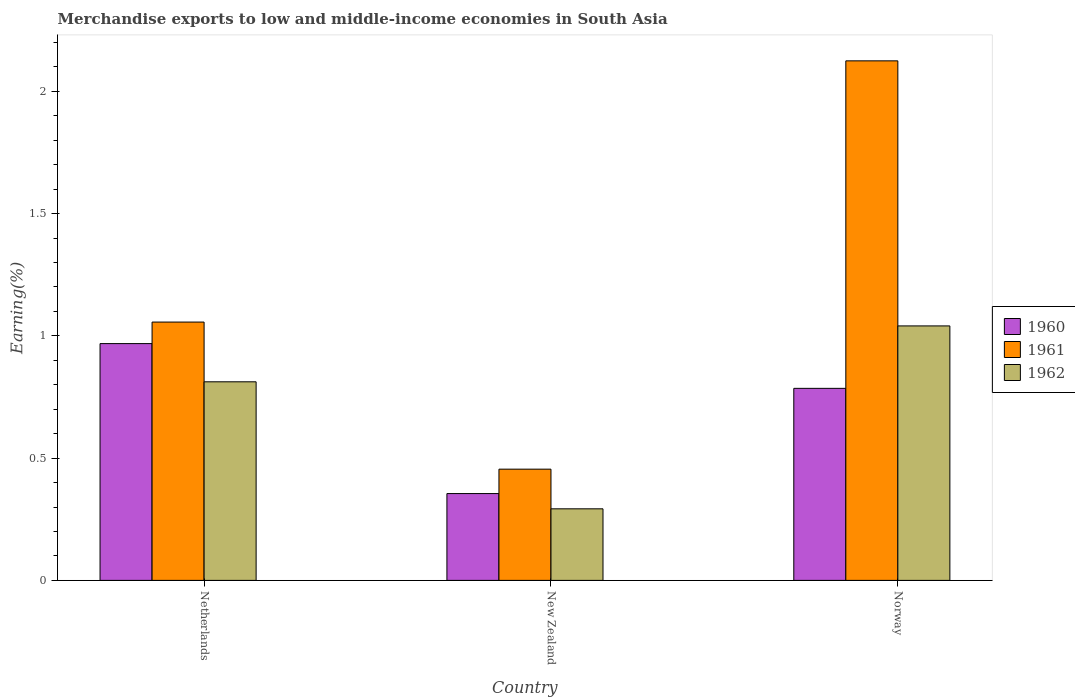How many groups of bars are there?
Give a very brief answer. 3. Are the number of bars per tick equal to the number of legend labels?
Your answer should be very brief. Yes. How many bars are there on the 3rd tick from the right?
Your answer should be very brief. 3. In how many cases, is the number of bars for a given country not equal to the number of legend labels?
Provide a succinct answer. 0. What is the percentage of amount earned from merchandise exports in 1961 in Norway?
Give a very brief answer. 2.12. Across all countries, what is the maximum percentage of amount earned from merchandise exports in 1962?
Ensure brevity in your answer.  1.04. Across all countries, what is the minimum percentage of amount earned from merchandise exports in 1962?
Ensure brevity in your answer.  0.29. In which country was the percentage of amount earned from merchandise exports in 1961 minimum?
Ensure brevity in your answer.  New Zealand. What is the total percentage of amount earned from merchandise exports in 1960 in the graph?
Keep it short and to the point. 2.11. What is the difference between the percentage of amount earned from merchandise exports in 1960 in New Zealand and that in Norway?
Provide a short and direct response. -0.43. What is the difference between the percentage of amount earned from merchandise exports in 1962 in Netherlands and the percentage of amount earned from merchandise exports in 1961 in New Zealand?
Provide a succinct answer. 0.36. What is the average percentage of amount earned from merchandise exports in 1960 per country?
Your response must be concise. 0.7. What is the difference between the percentage of amount earned from merchandise exports of/in 1960 and percentage of amount earned from merchandise exports of/in 1962 in New Zealand?
Offer a terse response. 0.06. What is the ratio of the percentage of amount earned from merchandise exports in 1962 in Netherlands to that in Norway?
Your response must be concise. 0.78. Is the percentage of amount earned from merchandise exports in 1961 in Netherlands less than that in New Zealand?
Offer a terse response. No. What is the difference between the highest and the second highest percentage of amount earned from merchandise exports in 1961?
Your answer should be very brief. -0.6. What is the difference between the highest and the lowest percentage of amount earned from merchandise exports in 1961?
Your answer should be very brief. 1.67. In how many countries, is the percentage of amount earned from merchandise exports in 1962 greater than the average percentage of amount earned from merchandise exports in 1962 taken over all countries?
Provide a succinct answer. 2. What does the 2nd bar from the right in Norway represents?
Ensure brevity in your answer.  1961. Is it the case that in every country, the sum of the percentage of amount earned from merchandise exports in 1960 and percentage of amount earned from merchandise exports in 1961 is greater than the percentage of amount earned from merchandise exports in 1962?
Your answer should be very brief. Yes. How many bars are there?
Provide a succinct answer. 9. How many countries are there in the graph?
Ensure brevity in your answer.  3. What is the difference between two consecutive major ticks on the Y-axis?
Offer a terse response. 0.5. Are the values on the major ticks of Y-axis written in scientific E-notation?
Offer a terse response. No. Does the graph contain any zero values?
Offer a terse response. No. How are the legend labels stacked?
Ensure brevity in your answer.  Vertical. What is the title of the graph?
Your answer should be very brief. Merchandise exports to low and middle-income economies in South Asia. Does "1967" appear as one of the legend labels in the graph?
Offer a terse response. No. What is the label or title of the X-axis?
Offer a terse response. Country. What is the label or title of the Y-axis?
Make the answer very short. Earning(%). What is the Earning(%) in 1960 in Netherlands?
Provide a short and direct response. 0.97. What is the Earning(%) in 1961 in Netherlands?
Your answer should be compact. 1.06. What is the Earning(%) in 1962 in Netherlands?
Your answer should be compact. 0.81. What is the Earning(%) of 1960 in New Zealand?
Provide a succinct answer. 0.36. What is the Earning(%) in 1961 in New Zealand?
Provide a short and direct response. 0.45. What is the Earning(%) of 1962 in New Zealand?
Offer a very short reply. 0.29. What is the Earning(%) of 1960 in Norway?
Make the answer very short. 0.79. What is the Earning(%) in 1961 in Norway?
Your answer should be compact. 2.12. What is the Earning(%) of 1962 in Norway?
Provide a succinct answer. 1.04. Across all countries, what is the maximum Earning(%) of 1960?
Keep it short and to the point. 0.97. Across all countries, what is the maximum Earning(%) of 1961?
Your answer should be very brief. 2.12. Across all countries, what is the maximum Earning(%) of 1962?
Your answer should be very brief. 1.04. Across all countries, what is the minimum Earning(%) in 1960?
Your answer should be very brief. 0.36. Across all countries, what is the minimum Earning(%) of 1961?
Make the answer very short. 0.45. Across all countries, what is the minimum Earning(%) in 1962?
Your answer should be very brief. 0.29. What is the total Earning(%) in 1960 in the graph?
Give a very brief answer. 2.11. What is the total Earning(%) in 1961 in the graph?
Provide a succinct answer. 3.64. What is the total Earning(%) of 1962 in the graph?
Provide a short and direct response. 2.15. What is the difference between the Earning(%) in 1960 in Netherlands and that in New Zealand?
Provide a short and direct response. 0.61. What is the difference between the Earning(%) in 1961 in Netherlands and that in New Zealand?
Provide a succinct answer. 0.6. What is the difference between the Earning(%) of 1962 in Netherlands and that in New Zealand?
Offer a very short reply. 0.52. What is the difference between the Earning(%) of 1960 in Netherlands and that in Norway?
Offer a terse response. 0.18. What is the difference between the Earning(%) in 1961 in Netherlands and that in Norway?
Offer a very short reply. -1.07. What is the difference between the Earning(%) of 1962 in Netherlands and that in Norway?
Keep it short and to the point. -0.23. What is the difference between the Earning(%) in 1960 in New Zealand and that in Norway?
Your response must be concise. -0.43. What is the difference between the Earning(%) of 1961 in New Zealand and that in Norway?
Ensure brevity in your answer.  -1.67. What is the difference between the Earning(%) in 1962 in New Zealand and that in Norway?
Your answer should be very brief. -0.75. What is the difference between the Earning(%) of 1960 in Netherlands and the Earning(%) of 1961 in New Zealand?
Make the answer very short. 0.51. What is the difference between the Earning(%) in 1960 in Netherlands and the Earning(%) in 1962 in New Zealand?
Provide a succinct answer. 0.68. What is the difference between the Earning(%) of 1961 in Netherlands and the Earning(%) of 1962 in New Zealand?
Offer a terse response. 0.76. What is the difference between the Earning(%) in 1960 in Netherlands and the Earning(%) in 1961 in Norway?
Your response must be concise. -1.16. What is the difference between the Earning(%) of 1960 in Netherlands and the Earning(%) of 1962 in Norway?
Offer a terse response. -0.07. What is the difference between the Earning(%) of 1961 in Netherlands and the Earning(%) of 1962 in Norway?
Provide a short and direct response. 0.02. What is the difference between the Earning(%) in 1960 in New Zealand and the Earning(%) in 1961 in Norway?
Your answer should be compact. -1.77. What is the difference between the Earning(%) in 1960 in New Zealand and the Earning(%) in 1962 in Norway?
Offer a terse response. -0.69. What is the difference between the Earning(%) of 1961 in New Zealand and the Earning(%) of 1962 in Norway?
Provide a succinct answer. -0.59. What is the average Earning(%) of 1960 per country?
Offer a terse response. 0.7. What is the average Earning(%) of 1961 per country?
Make the answer very short. 1.21. What is the average Earning(%) of 1962 per country?
Make the answer very short. 0.72. What is the difference between the Earning(%) of 1960 and Earning(%) of 1961 in Netherlands?
Provide a short and direct response. -0.09. What is the difference between the Earning(%) in 1960 and Earning(%) in 1962 in Netherlands?
Ensure brevity in your answer.  0.16. What is the difference between the Earning(%) in 1961 and Earning(%) in 1962 in Netherlands?
Your answer should be compact. 0.24. What is the difference between the Earning(%) of 1960 and Earning(%) of 1961 in New Zealand?
Offer a terse response. -0.1. What is the difference between the Earning(%) of 1960 and Earning(%) of 1962 in New Zealand?
Offer a terse response. 0.06. What is the difference between the Earning(%) in 1961 and Earning(%) in 1962 in New Zealand?
Provide a succinct answer. 0.16. What is the difference between the Earning(%) in 1960 and Earning(%) in 1961 in Norway?
Your response must be concise. -1.34. What is the difference between the Earning(%) of 1960 and Earning(%) of 1962 in Norway?
Your answer should be compact. -0.26. What is the difference between the Earning(%) of 1961 and Earning(%) of 1962 in Norway?
Provide a succinct answer. 1.08. What is the ratio of the Earning(%) of 1960 in Netherlands to that in New Zealand?
Provide a short and direct response. 2.73. What is the ratio of the Earning(%) of 1961 in Netherlands to that in New Zealand?
Provide a short and direct response. 2.32. What is the ratio of the Earning(%) in 1962 in Netherlands to that in New Zealand?
Provide a short and direct response. 2.78. What is the ratio of the Earning(%) of 1960 in Netherlands to that in Norway?
Ensure brevity in your answer.  1.23. What is the ratio of the Earning(%) in 1961 in Netherlands to that in Norway?
Provide a short and direct response. 0.5. What is the ratio of the Earning(%) of 1962 in Netherlands to that in Norway?
Offer a very short reply. 0.78. What is the ratio of the Earning(%) in 1960 in New Zealand to that in Norway?
Your answer should be compact. 0.45. What is the ratio of the Earning(%) in 1961 in New Zealand to that in Norway?
Provide a succinct answer. 0.21. What is the ratio of the Earning(%) in 1962 in New Zealand to that in Norway?
Your response must be concise. 0.28. What is the difference between the highest and the second highest Earning(%) in 1960?
Your answer should be very brief. 0.18. What is the difference between the highest and the second highest Earning(%) in 1961?
Make the answer very short. 1.07. What is the difference between the highest and the second highest Earning(%) of 1962?
Provide a succinct answer. 0.23. What is the difference between the highest and the lowest Earning(%) in 1960?
Provide a short and direct response. 0.61. What is the difference between the highest and the lowest Earning(%) of 1961?
Give a very brief answer. 1.67. What is the difference between the highest and the lowest Earning(%) in 1962?
Offer a terse response. 0.75. 